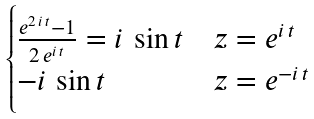Convert formula to latex. <formula><loc_0><loc_0><loc_500><loc_500>\begin{cases} \frac { e ^ { 2 \, i \, t } - 1 } { 2 \, e ^ { i \, t } } = i \, \sin t & z = e ^ { i \, t } \\ - i \, \sin t & z = e ^ { - i \, t } \end{cases}</formula> 